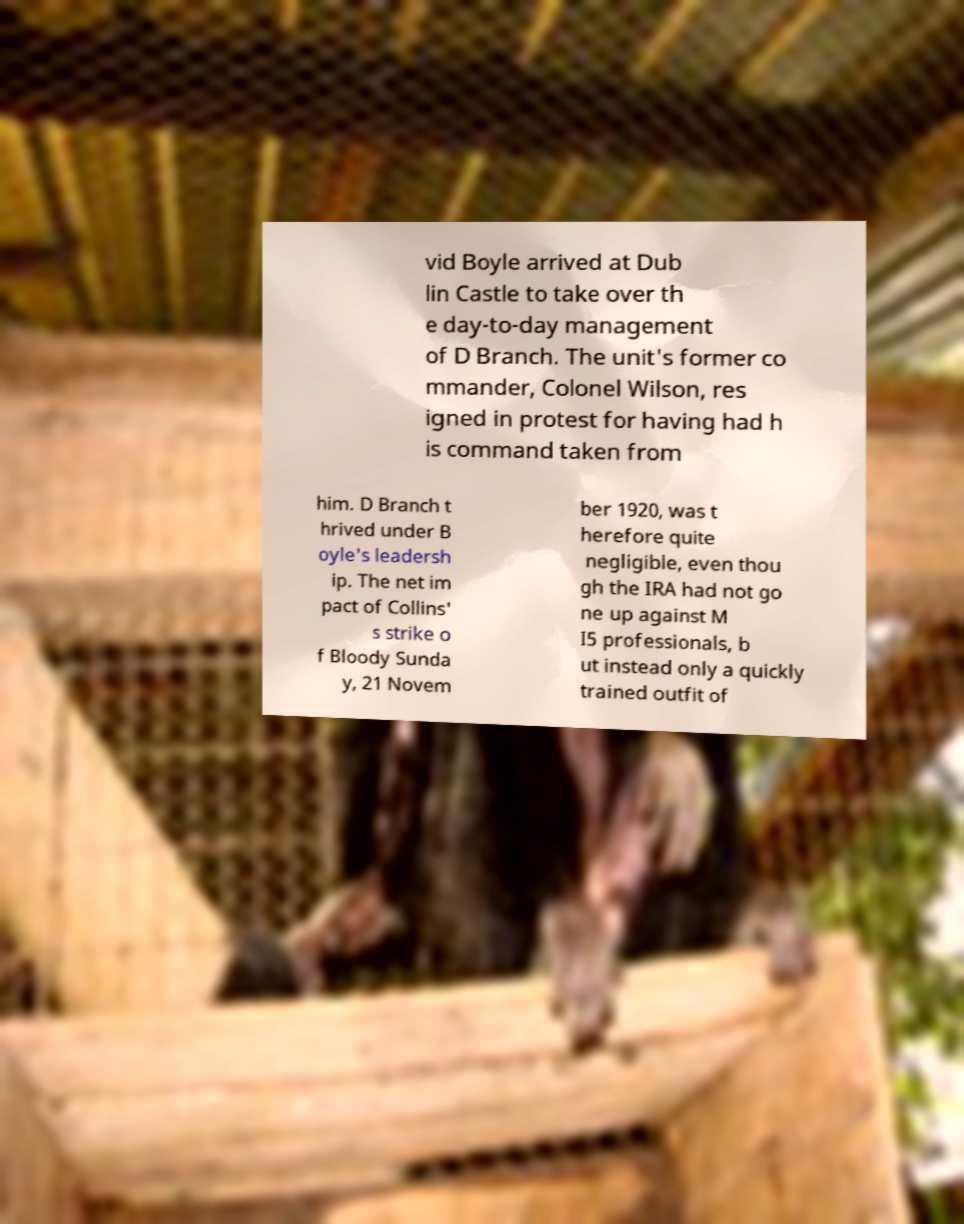Please identify and transcribe the text found in this image. vid Boyle arrived at Dub lin Castle to take over th e day-to-day management of D Branch. The unit's former co mmander, Colonel Wilson, res igned in protest for having had h is command taken from him. D Branch t hrived under B oyle's leadersh ip. The net im pact of Collins' s strike o f Bloody Sunda y, 21 Novem ber 1920, was t herefore quite negligible, even thou gh the IRA had not go ne up against M I5 professionals, b ut instead only a quickly trained outfit of 